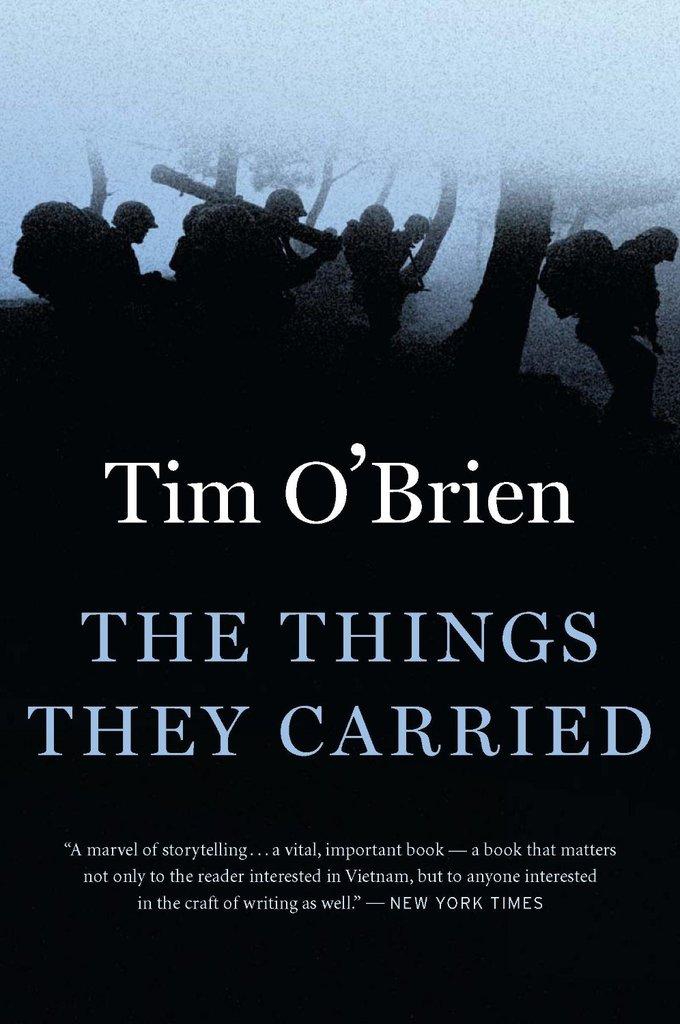Who wrote this book?
Your response must be concise. Tim o'brien. What is the title of this book?
Your response must be concise. The things they carried. 